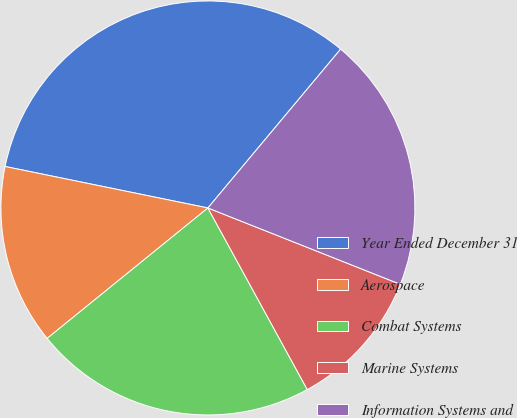Convert chart to OTSL. <chart><loc_0><loc_0><loc_500><loc_500><pie_chart><fcel>Year Ended December 31<fcel>Aerospace<fcel>Combat Systems<fcel>Marine Systems<fcel>Information Systems and<nl><fcel>32.87%<fcel>14.06%<fcel>22.12%<fcel>11.02%<fcel>19.93%<nl></chart> 